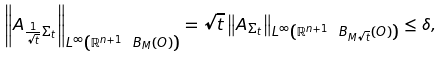Convert formula to latex. <formula><loc_0><loc_0><loc_500><loc_500>\left \| A _ { \frac { 1 } { \sqrt { t } } \Sigma _ { t } } \right \| _ { L ^ { \infty } \left ( \mathbb { R } ^ { n + 1 } \ B _ { M } \left ( O \right ) \right ) } = \sqrt { t } \left \| A _ { \Sigma _ { t } } \right \| _ { L ^ { \infty } \left ( \mathbb { R } ^ { n + 1 } \ B _ { M \sqrt { t } } \left ( O \right ) \right ) } \leq \delta ,</formula> 